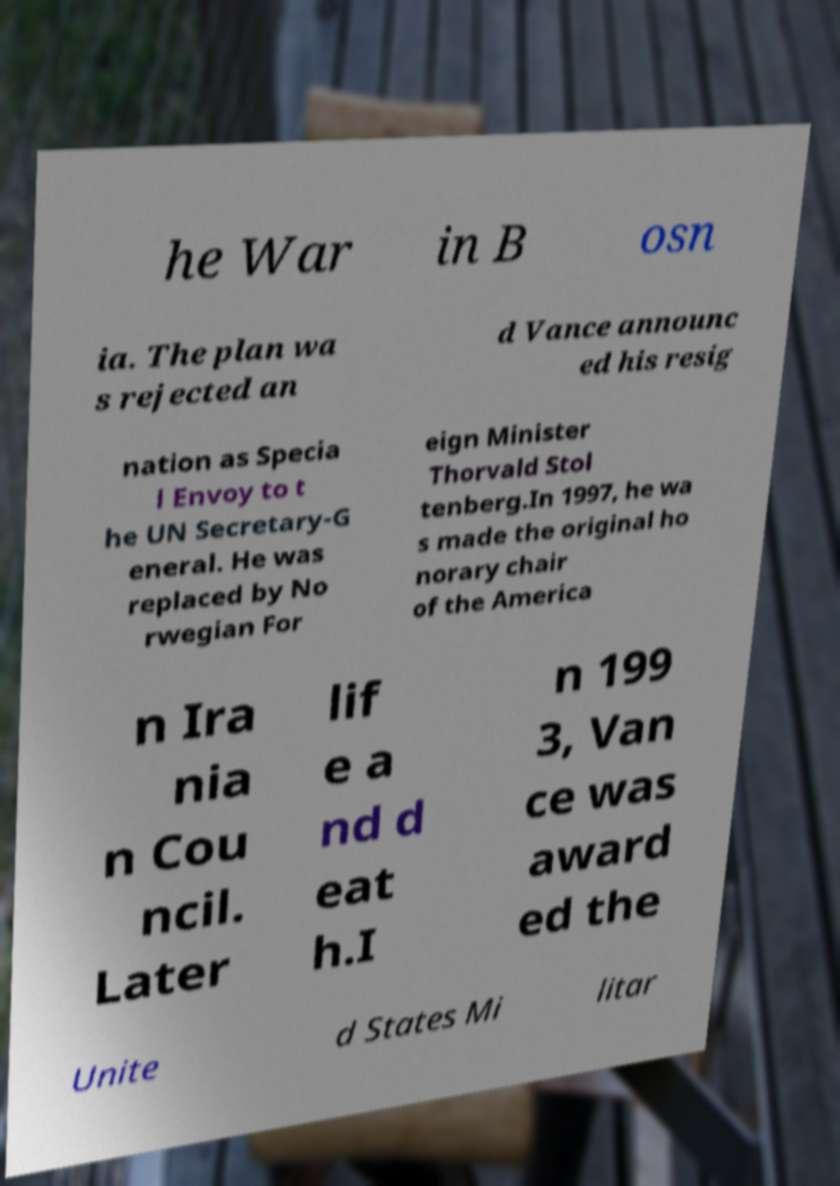Please read and relay the text visible in this image. What does it say? he War in B osn ia. The plan wa s rejected an d Vance announc ed his resig nation as Specia l Envoy to t he UN Secretary-G eneral. He was replaced by No rwegian For eign Minister Thorvald Stol tenberg.In 1997, he wa s made the original ho norary chair of the America n Ira nia n Cou ncil. Later lif e a nd d eat h.I n 199 3, Van ce was award ed the Unite d States Mi litar 